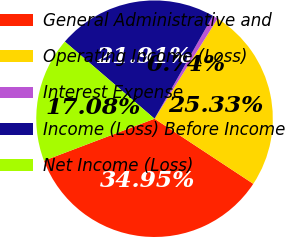Convert chart. <chart><loc_0><loc_0><loc_500><loc_500><pie_chart><fcel>General Administrative and<fcel>Operating Income (Loss)<fcel>Interest Expense<fcel>Income (Loss) Before Income<fcel>Net Income (Loss)<nl><fcel>34.95%<fcel>25.33%<fcel>0.74%<fcel>21.91%<fcel>17.08%<nl></chart> 